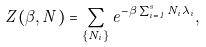Convert formula to latex. <formula><loc_0><loc_0><loc_500><loc_500>Z ( \beta , N ) = \sum _ { \{ N _ { i } \} } e ^ { - \beta \sum _ { i = 1 } ^ { s } N _ { i } \lambda _ { i } } ,</formula> 